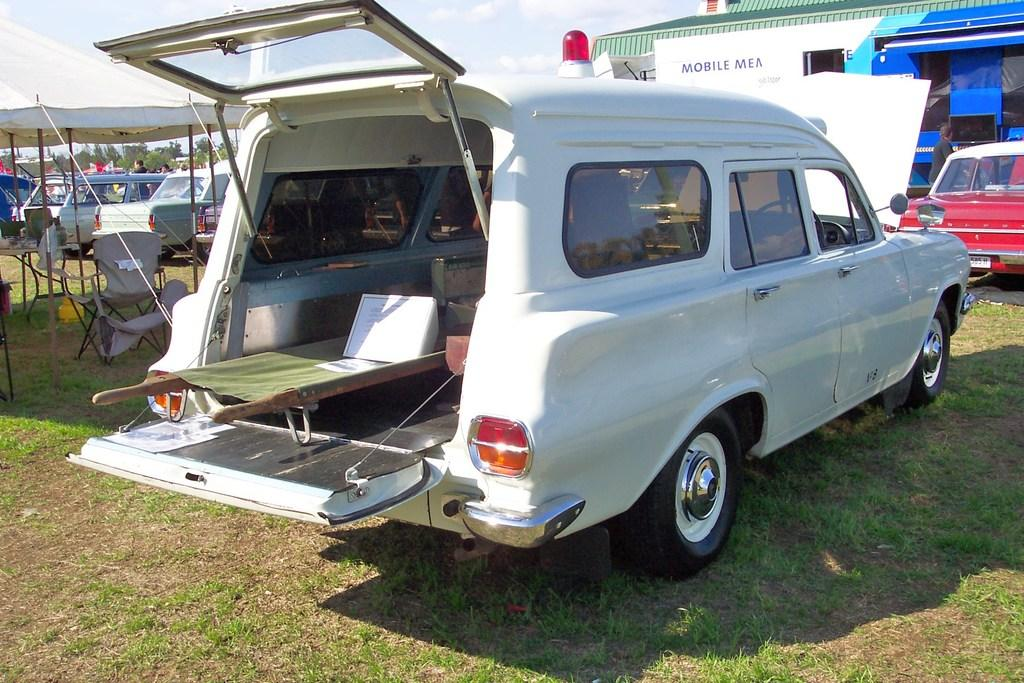What types of objects are present in the image? There are vehicles, a tent, chairs, and a rooftop in the image. What is the setting of the image? The image features a rooftop with grass, trees, and people visible in the background. The sky is also visible, with clouds present. Can you describe the objects that people might use for sitting or resting? There are chairs in the image that people might use for sitting or resting. Are there any structures or shelters visible in the image? Yes, there is a tent in the image that could serve as a shelter. What rate is the clock ticking at in the image? There is no clock present in the image, so it is not possible to determine the rate at which it might be ticking. What type of chalk is being used to draw on the rooftop in the image? There is no chalk or drawing activity visible in the image. 